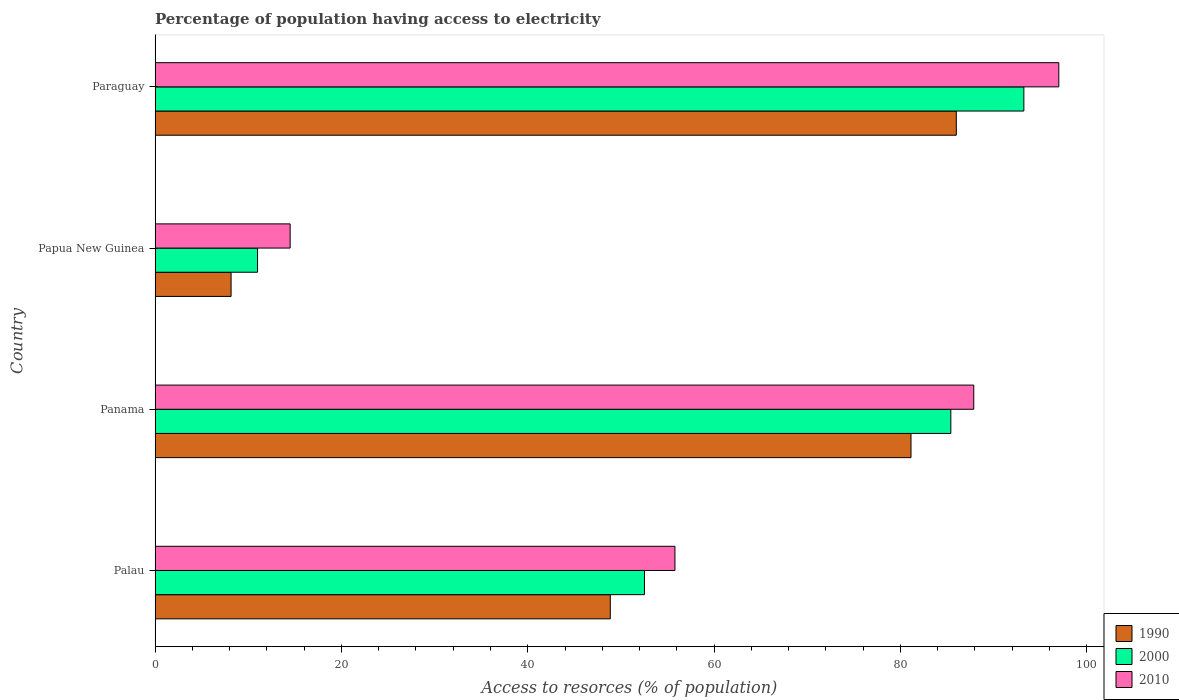How many different coloured bars are there?
Provide a short and direct response. 3. Are the number of bars per tick equal to the number of legend labels?
Your answer should be compact. Yes. How many bars are there on the 4th tick from the top?
Your response must be concise. 3. What is the label of the 4th group of bars from the top?
Provide a succinct answer. Palau. Across all countries, what is the maximum percentage of population having access to electricity in 2000?
Your answer should be compact. 93.25. In which country was the percentage of population having access to electricity in 1990 maximum?
Offer a terse response. Paraguay. In which country was the percentage of population having access to electricity in 2000 minimum?
Offer a terse response. Papua New Guinea. What is the total percentage of population having access to electricity in 1990 in the graph?
Give a very brief answer. 224.15. What is the difference between the percentage of population having access to electricity in 2010 in Palau and that in Panama?
Offer a terse response. -32.07. What is the difference between the percentage of population having access to electricity in 2000 in Papua New Guinea and the percentage of population having access to electricity in 1990 in Palau?
Your answer should be very brief. -37.86. What is the average percentage of population having access to electricity in 2000 per country?
Offer a very short reply. 60.55. What is the difference between the percentage of population having access to electricity in 2010 and percentage of population having access to electricity in 1990 in Paraguay?
Your answer should be very brief. 11. What is the ratio of the percentage of population having access to electricity in 2000 in Papua New Guinea to that in Paraguay?
Your answer should be compact. 0.12. What is the difference between the highest and the second highest percentage of population having access to electricity in 2010?
Provide a succinct answer. 9.13. What is the difference between the highest and the lowest percentage of population having access to electricity in 1990?
Keep it short and to the point. 77.84. In how many countries, is the percentage of population having access to electricity in 1990 greater than the average percentage of population having access to electricity in 1990 taken over all countries?
Make the answer very short. 2. Is the sum of the percentage of population having access to electricity in 2000 in Panama and Paraguay greater than the maximum percentage of population having access to electricity in 1990 across all countries?
Offer a very short reply. Yes. What does the 2nd bar from the top in Palau represents?
Give a very brief answer. 2000. How many bars are there?
Provide a succinct answer. 12. Are all the bars in the graph horizontal?
Ensure brevity in your answer.  Yes. How many countries are there in the graph?
Your response must be concise. 4. What is the difference between two consecutive major ticks on the X-axis?
Provide a short and direct response. 20. Does the graph contain any zero values?
Provide a short and direct response. No. Does the graph contain grids?
Keep it short and to the point. No. Where does the legend appear in the graph?
Offer a terse response. Bottom right. How are the legend labels stacked?
Give a very brief answer. Vertical. What is the title of the graph?
Your response must be concise. Percentage of population having access to electricity. What is the label or title of the X-axis?
Offer a terse response. Access to resorces (% of population). What is the label or title of the Y-axis?
Your response must be concise. Country. What is the Access to resorces (% of population) of 1990 in Palau?
Give a very brief answer. 48.86. What is the Access to resorces (% of population) in 2000 in Palau?
Keep it short and to the point. 52.53. What is the Access to resorces (% of population) in 2010 in Palau?
Provide a short and direct response. 55.8. What is the Access to resorces (% of population) of 1990 in Panama?
Your response must be concise. 81.14. What is the Access to resorces (% of population) of 2000 in Panama?
Give a very brief answer. 85.41. What is the Access to resorces (% of population) of 2010 in Panama?
Your response must be concise. 87.87. What is the Access to resorces (% of population) of 1990 in Papua New Guinea?
Provide a short and direct response. 8.16. What is the Access to resorces (% of population) of 2000 in Papua New Guinea?
Offer a very short reply. 11. What is the Access to resorces (% of population) in 2010 in Papua New Guinea?
Your answer should be very brief. 14.5. What is the Access to resorces (% of population) of 2000 in Paraguay?
Provide a succinct answer. 93.25. What is the Access to resorces (% of population) of 2010 in Paraguay?
Offer a terse response. 97. Across all countries, what is the maximum Access to resorces (% of population) in 2000?
Make the answer very short. 93.25. Across all countries, what is the maximum Access to resorces (% of population) of 2010?
Keep it short and to the point. 97. Across all countries, what is the minimum Access to resorces (% of population) in 1990?
Offer a very short reply. 8.16. Across all countries, what is the minimum Access to resorces (% of population) of 2010?
Make the answer very short. 14.5. What is the total Access to resorces (% of population) of 1990 in the graph?
Your answer should be compact. 224.15. What is the total Access to resorces (% of population) in 2000 in the graph?
Offer a terse response. 242.19. What is the total Access to resorces (% of population) in 2010 in the graph?
Provide a short and direct response. 255.17. What is the difference between the Access to resorces (% of population) in 1990 in Palau and that in Panama?
Make the answer very short. -32.28. What is the difference between the Access to resorces (% of population) of 2000 in Palau and that in Panama?
Ensure brevity in your answer.  -32.88. What is the difference between the Access to resorces (% of population) of 2010 in Palau and that in Panama?
Offer a terse response. -32.07. What is the difference between the Access to resorces (% of population) of 1990 in Palau and that in Papua New Guinea?
Keep it short and to the point. 40.7. What is the difference between the Access to resorces (% of population) in 2000 in Palau and that in Papua New Guinea?
Your answer should be very brief. 41.53. What is the difference between the Access to resorces (% of population) of 2010 in Palau and that in Papua New Guinea?
Ensure brevity in your answer.  41.3. What is the difference between the Access to resorces (% of population) in 1990 in Palau and that in Paraguay?
Provide a succinct answer. -37.14. What is the difference between the Access to resorces (% of population) of 2000 in Palau and that in Paraguay?
Offer a very short reply. -40.72. What is the difference between the Access to resorces (% of population) in 2010 in Palau and that in Paraguay?
Provide a short and direct response. -41.2. What is the difference between the Access to resorces (% of population) of 1990 in Panama and that in Papua New Guinea?
Offer a very short reply. 72.98. What is the difference between the Access to resorces (% of population) in 2000 in Panama and that in Papua New Guinea?
Provide a short and direct response. 74.41. What is the difference between the Access to resorces (% of population) of 2010 in Panama and that in Papua New Guinea?
Offer a very short reply. 73.37. What is the difference between the Access to resorces (% of population) of 1990 in Panama and that in Paraguay?
Keep it short and to the point. -4.86. What is the difference between the Access to resorces (% of population) of 2000 in Panama and that in Paraguay?
Keep it short and to the point. -7.84. What is the difference between the Access to resorces (% of population) of 2010 in Panama and that in Paraguay?
Make the answer very short. -9.13. What is the difference between the Access to resorces (% of population) in 1990 in Papua New Guinea and that in Paraguay?
Make the answer very short. -77.84. What is the difference between the Access to resorces (% of population) in 2000 in Papua New Guinea and that in Paraguay?
Your answer should be compact. -82.25. What is the difference between the Access to resorces (% of population) of 2010 in Papua New Guinea and that in Paraguay?
Your answer should be compact. -82.5. What is the difference between the Access to resorces (% of population) in 1990 in Palau and the Access to resorces (% of population) in 2000 in Panama?
Your answer should be very brief. -36.55. What is the difference between the Access to resorces (% of population) in 1990 in Palau and the Access to resorces (% of population) in 2010 in Panama?
Keep it short and to the point. -39.01. What is the difference between the Access to resorces (% of population) in 2000 in Palau and the Access to resorces (% of population) in 2010 in Panama?
Provide a succinct answer. -35.34. What is the difference between the Access to resorces (% of population) of 1990 in Palau and the Access to resorces (% of population) of 2000 in Papua New Guinea?
Your answer should be very brief. 37.86. What is the difference between the Access to resorces (% of population) of 1990 in Palau and the Access to resorces (% of population) of 2010 in Papua New Guinea?
Your response must be concise. 34.36. What is the difference between the Access to resorces (% of population) in 2000 in Palau and the Access to resorces (% of population) in 2010 in Papua New Guinea?
Your response must be concise. 38.03. What is the difference between the Access to resorces (% of population) of 1990 in Palau and the Access to resorces (% of population) of 2000 in Paraguay?
Give a very brief answer. -44.39. What is the difference between the Access to resorces (% of population) in 1990 in Palau and the Access to resorces (% of population) in 2010 in Paraguay?
Your answer should be compact. -48.14. What is the difference between the Access to resorces (% of population) in 2000 in Palau and the Access to resorces (% of population) in 2010 in Paraguay?
Keep it short and to the point. -44.47. What is the difference between the Access to resorces (% of population) of 1990 in Panama and the Access to resorces (% of population) of 2000 in Papua New Guinea?
Ensure brevity in your answer.  70.14. What is the difference between the Access to resorces (% of population) in 1990 in Panama and the Access to resorces (% of population) in 2010 in Papua New Guinea?
Provide a short and direct response. 66.64. What is the difference between the Access to resorces (% of population) in 2000 in Panama and the Access to resorces (% of population) in 2010 in Papua New Guinea?
Your answer should be very brief. 70.91. What is the difference between the Access to resorces (% of population) of 1990 in Panama and the Access to resorces (% of population) of 2000 in Paraguay?
Make the answer very short. -12.11. What is the difference between the Access to resorces (% of population) of 1990 in Panama and the Access to resorces (% of population) of 2010 in Paraguay?
Make the answer very short. -15.86. What is the difference between the Access to resorces (% of population) in 2000 in Panama and the Access to resorces (% of population) in 2010 in Paraguay?
Provide a short and direct response. -11.59. What is the difference between the Access to resorces (% of population) in 1990 in Papua New Guinea and the Access to resorces (% of population) in 2000 in Paraguay?
Your response must be concise. -85.09. What is the difference between the Access to resorces (% of population) of 1990 in Papua New Guinea and the Access to resorces (% of population) of 2010 in Paraguay?
Your response must be concise. -88.84. What is the difference between the Access to resorces (% of population) of 2000 in Papua New Guinea and the Access to resorces (% of population) of 2010 in Paraguay?
Your answer should be very brief. -86. What is the average Access to resorces (% of population) in 1990 per country?
Your response must be concise. 56.04. What is the average Access to resorces (% of population) in 2000 per country?
Your answer should be compact. 60.55. What is the average Access to resorces (% of population) in 2010 per country?
Your answer should be compact. 63.79. What is the difference between the Access to resorces (% of population) in 1990 and Access to resorces (% of population) in 2000 in Palau?
Keep it short and to the point. -3.67. What is the difference between the Access to resorces (% of population) of 1990 and Access to resorces (% of population) of 2010 in Palau?
Your response must be concise. -6.94. What is the difference between the Access to resorces (% of population) of 2000 and Access to resorces (% of population) of 2010 in Palau?
Your answer should be very brief. -3.27. What is the difference between the Access to resorces (% of population) of 1990 and Access to resorces (% of population) of 2000 in Panama?
Make the answer very short. -4.28. What is the difference between the Access to resorces (% of population) of 1990 and Access to resorces (% of population) of 2010 in Panama?
Make the answer very short. -6.74. What is the difference between the Access to resorces (% of population) of 2000 and Access to resorces (% of population) of 2010 in Panama?
Your answer should be very brief. -2.46. What is the difference between the Access to resorces (% of population) in 1990 and Access to resorces (% of population) in 2000 in Papua New Guinea?
Your answer should be very brief. -2.84. What is the difference between the Access to resorces (% of population) of 1990 and Access to resorces (% of population) of 2010 in Papua New Guinea?
Make the answer very short. -6.34. What is the difference between the Access to resorces (% of population) of 2000 and Access to resorces (% of population) of 2010 in Papua New Guinea?
Provide a succinct answer. -3.5. What is the difference between the Access to resorces (% of population) in 1990 and Access to resorces (% of population) in 2000 in Paraguay?
Give a very brief answer. -7.25. What is the difference between the Access to resorces (% of population) of 1990 and Access to resorces (% of population) of 2010 in Paraguay?
Keep it short and to the point. -11. What is the difference between the Access to resorces (% of population) in 2000 and Access to resorces (% of population) in 2010 in Paraguay?
Your answer should be compact. -3.75. What is the ratio of the Access to resorces (% of population) in 1990 in Palau to that in Panama?
Keep it short and to the point. 0.6. What is the ratio of the Access to resorces (% of population) of 2000 in Palau to that in Panama?
Your answer should be compact. 0.61. What is the ratio of the Access to resorces (% of population) of 2010 in Palau to that in Panama?
Offer a terse response. 0.64. What is the ratio of the Access to resorces (% of population) of 1990 in Palau to that in Papua New Guinea?
Make the answer very short. 5.99. What is the ratio of the Access to resorces (% of population) in 2000 in Palau to that in Papua New Guinea?
Give a very brief answer. 4.78. What is the ratio of the Access to resorces (% of population) in 2010 in Palau to that in Papua New Guinea?
Your response must be concise. 3.85. What is the ratio of the Access to resorces (% of population) of 1990 in Palau to that in Paraguay?
Give a very brief answer. 0.57. What is the ratio of the Access to resorces (% of population) in 2000 in Palau to that in Paraguay?
Offer a terse response. 0.56. What is the ratio of the Access to resorces (% of population) in 2010 in Palau to that in Paraguay?
Provide a short and direct response. 0.58. What is the ratio of the Access to resorces (% of population) in 1990 in Panama to that in Papua New Guinea?
Keep it short and to the point. 9.94. What is the ratio of the Access to resorces (% of population) in 2000 in Panama to that in Papua New Guinea?
Your response must be concise. 7.76. What is the ratio of the Access to resorces (% of population) in 2010 in Panama to that in Papua New Guinea?
Offer a very short reply. 6.06. What is the ratio of the Access to resorces (% of population) of 1990 in Panama to that in Paraguay?
Make the answer very short. 0.94. What is the ratio of the Access to resorces (% of population) in 2000 in Panama to that in Paraguay?
Provide a short and direct response. 0.92. What is the ratio of the Access to resorces (% of population) in 2010 in Panama to that in Paraguay?
Provide a succinct answer. 0.91. What is the ratio of the Access to resorces (% of population) in 1990 in Papua New Guinea to that in Paraguay?
Your response must be concise. 0.09. What is the ratio of the Access to resorces (% of population) in 2000 in Papua New Guinea to that in Paraguay?
Keep it short and to the point. 0.12. What is the ratio of the Access to resorces (% of population) of 2010 in Papua New Guinea to that in Paraguay?
Offer a terse response. 0.15. What is the difference between the highest and the second highest Access to resorces (% of population) in 1990?
Provide a short and direct response. 4.86. What is the difference between the highest and the second highest Access to resorces (% of population) in 2000?
Your response must be concise. 7.84. What is the difference between the highest and the second highest Access to resorces (% of population) of 2010?
Offer a very short reply. 9.13. What is the difference between the highest and the lowest Access to resorces (% of population) of 1990?
Your answer should be very brief. 77.84. What is the difference between the highest and the lowest Access to resorces (% of population) of 2000?
Your response must be concise. 82.25. What is the difference between the highest and the lowest Access to resorces (% of population) of 2010?
Your response must be concise. 82.5. 